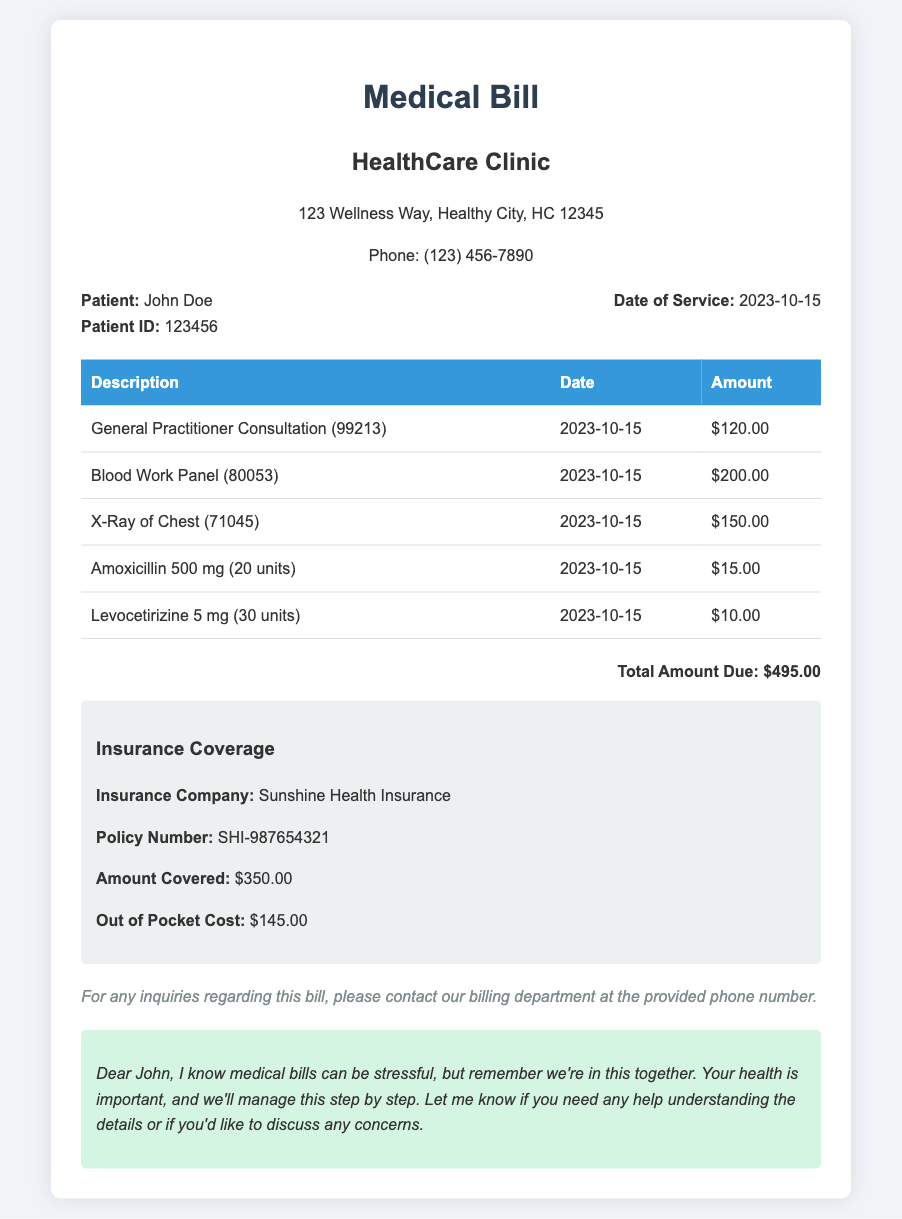What is the patient's name? The document clearly states the patient's name at the top under patient info.
Answer: John Doe What is the total amount due? The total amount due is located at the bottom of the bill, summarizing all charges.
Answer: $495.00 What is the date of service? The service date is listed in the patient info section.
Answer: 2023-10-15 How much did insurance cover? The amount covered by insurance is detailed in the insurance coverage section of the document.
Answer: $350.00 What medication was prescribed along with the quantity? The document lists the medications and their quantities in the itemized charges table.
Answer: Amoxicillin 500 mg (20 units) What is the out-of-pocket cost? The out-of-pocket cost is mentioned in the insurance section of the document.
Answer: $145.00 How many different services and medications are listed? By counting the rows in the itemized charges table, we can determine the total number of services and medications provided.
Answer: 5 Which provider issued this bill? The provider's name is noted at the top of the document under provider info.
Answer: HealthCare Clinic What is the patient's ID number? The patient ID number is provided in the patient info section of the document.
Answer: 123456 